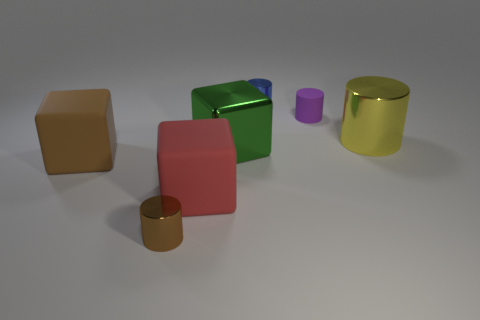What is the shape of the other metallic thing that is the same size as the green thing?
Offer a very short reply. Cylinder. Are there any yellow things of the same shape as the tiny brown metallic object?
Offer a very short reply. Yes. Are there any big metallic things that are left of the tiny metallic cylinder that is behind the purple cylinder right of the blue cylinder?
Your answer should be very brief. Yes. Are there more brown blocks in front of the yellow cylinder than big metal blocks that are in front of the big brown cube?
Provide a succinct answer. Yes. What material is the brown cylinder that is the same size as the purple object?
Give a very brief answer. Metal. What number of big objects are shiny cylinders or purple cylinders?
Keep it short and to the point. 1. Is the yellow object the same shape as the blue metal thing?
Your answer should be compact. Yes. What number of blocks are both left of the big green metallic object and to the right of the tiny brown cylinder?
Ensure brevity in your answer.  1. Are there any other things that are the same color as the small rubber object?
Keep it short and to the point. No. What is the shape of the tiny thing that is the same material as the brown cube?
Your response must be concise. Cylinder. 